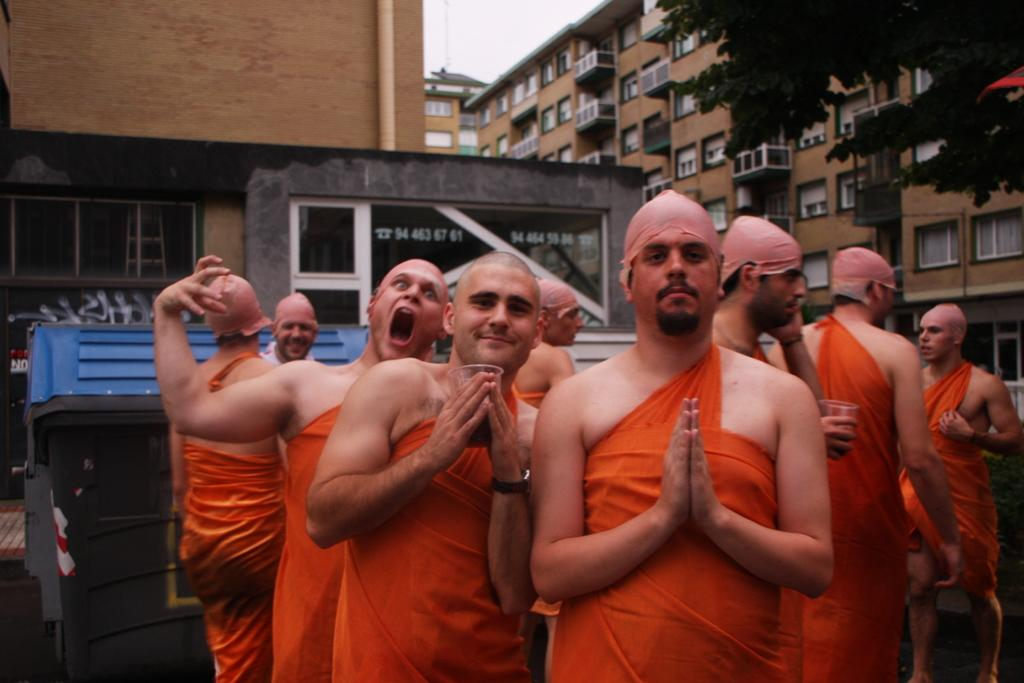What can be seen in the image? There are groups of people in the image. What are the people wearing? The people are wearing orange dresses. What is visible in the background of the image? There is a tree, buildings, and the sky visible in the background of the image. What type of hand can be seen holding a basketball in the image? There is no hand or basketball present in the image. Where did the people in the image go on vacation? The image does not provide any information about the people going on vacation. 